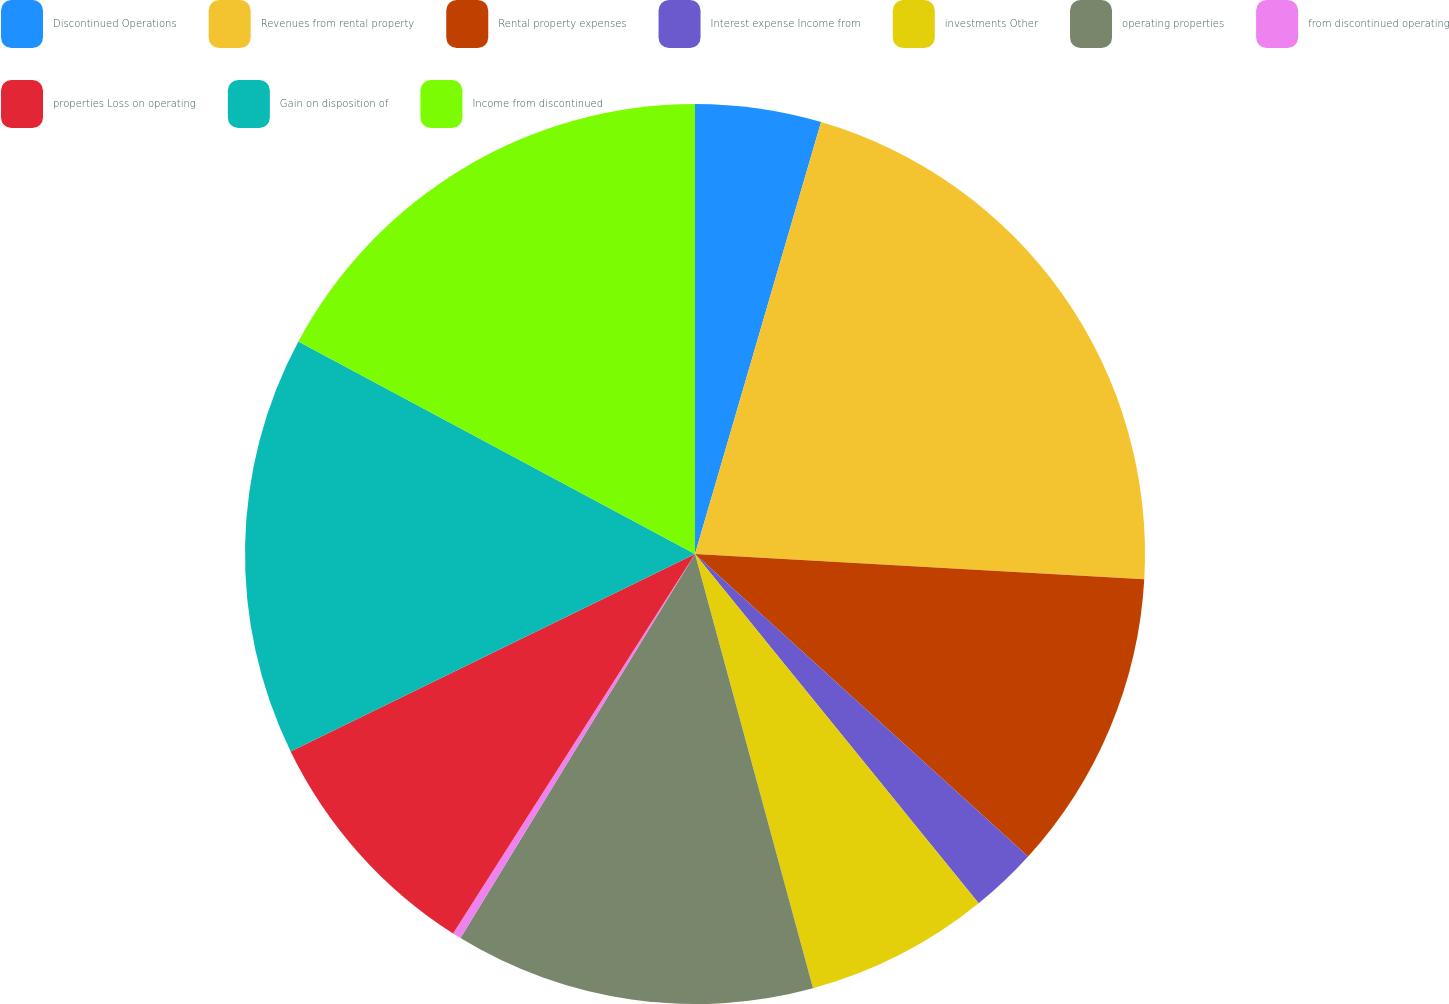Convert chart. <chart><loc_0><loc_0><loc_500><loc_500><pie_chart><fcel>Discontinued Operations<fcel>Revenues from rental property<fcel>Rental property expenses<fcel>Interest expense Income from<fcel>investments Other<fcel>operating properties<fcel>from discontinued operating<fcel>properties Loss on operating<fcel>Gain on disposition of<fcel>Income from discontinued<nl><fcel>4.52%<fcel>21.38%<fcel>10.84%<fcel>2.41%<fcel>6.63%<fcel>12.95%<fcel>0.31%<fcel>8.74%<fcel>15.06%<fcel>17.17%<nl></chart> 